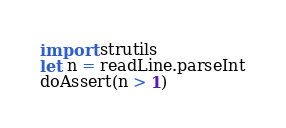Convert code to text. <code><loc_0><loc_0><loc_500><loc_500><_Nim_>import strutils
let n = readLine.parseInt
doAssert(n > 1)
</code> 